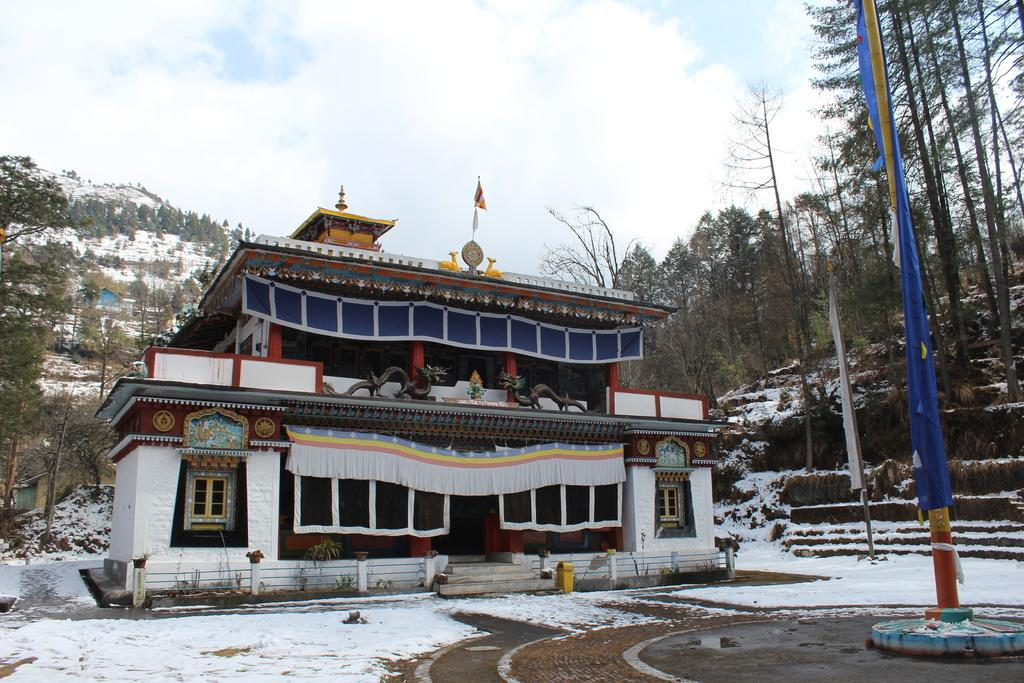What type of structure is visible in the image? There is a building in the image. Can you describe the color of the building? The building is white. What can be seen in the background of the image? There are trees in the background of the image. How would you describe the sky in the image? The sky is blue and white. What is the weather like in the image? The presence of snow suggests that it is likely cold and possibly snowy. What type of toad can be seen hopping on the roof of the building in the image? There is no toad present in the image, and therefore no such activity can be observed. 